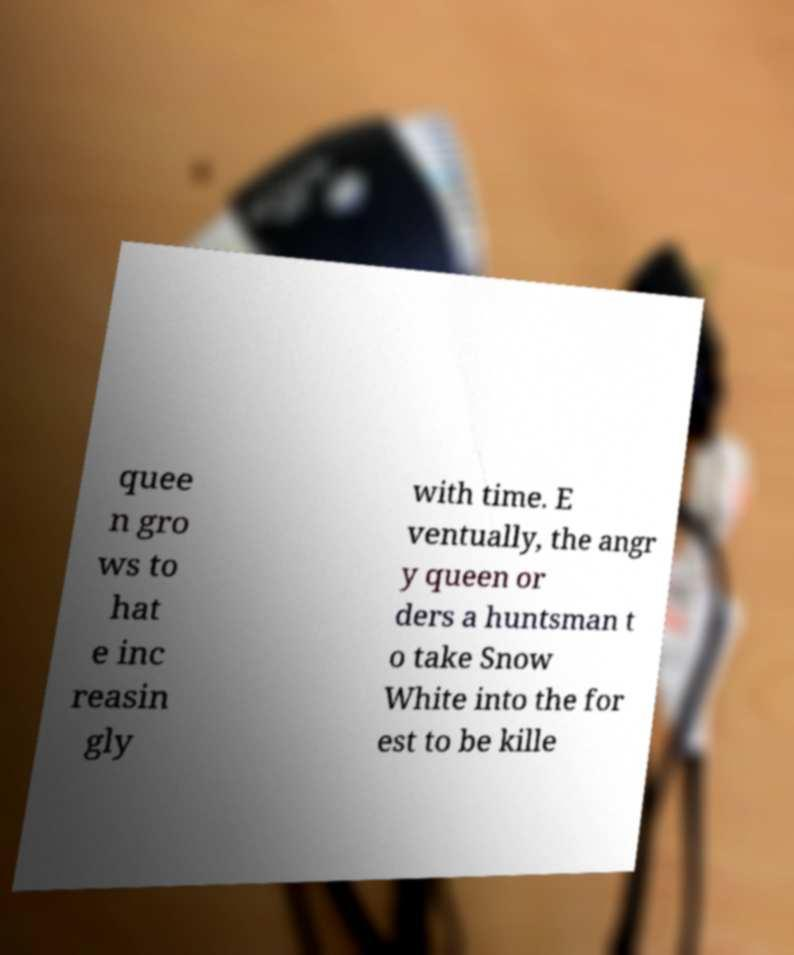Please read and relay the text visible in this image. What does it say? quee n gro ws to hat e inc reasin gly with time. E ventually, the angr y queen or ders a huntsman t o take Snow White into the for est to be kille 